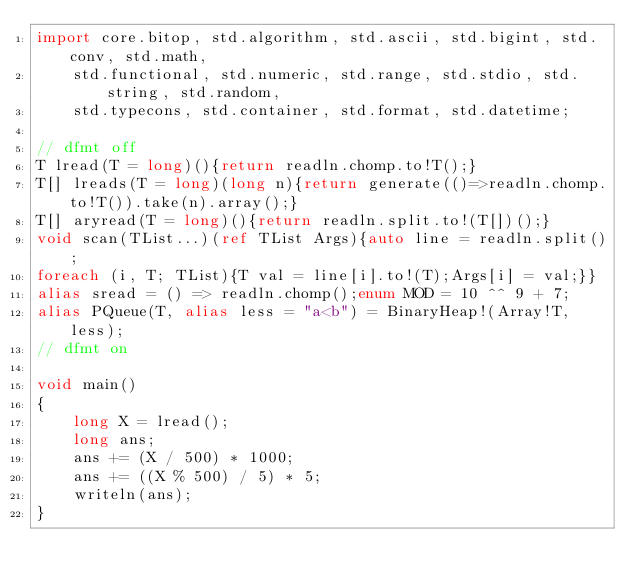<code> <loc_0><loc_0><loc_500><loc_500><_D_>import core.bitop, std.algorithm, std.ascii, std.bigint, std.conv, std.math,
    std.functional, std.numeric, std.range, std.stdio, std.string, std.random,
    std.typecons, std.container, std.format, std.datetime;

// dfmt off
T lread(T = long)(){return readln.chomp.to!T();}
T[] lreads(T = long)(long n){return generate(()=>readln.chomp.to!T()).take(n).array();}
T[] aryread(T = long)(){return readln.split.to!(T[])();}
void scan(TList...)(ref TList Args){auto line = readln.split();
foreach (i, T; TList){T val = line[i].to!(T);Args[i] = val;}}
alias sread = () => readln.chomp();enum MOD = 10 ^^ 9 + 7;
alias PQueue(T, alias less = "a<b") = BinaryHeap!(Array!T, less);
// dfmt on

void main()
{
    long X = lread();
    long ans;
    ans += (X / 500) * 1000;
    ans += ((X % 500) / 5) * 5;
    writeln(ans);
}
</code> 